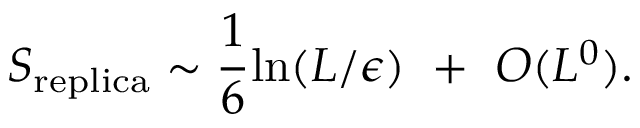<formula> <loc_0><loc_0><loc_500><loc_500>S _ { r e p l i c a } \sim { \frac { 1 } { 6 } } \ln ( L / \epsilon ) + O ( L ^ { 0 } ) .</formula> 